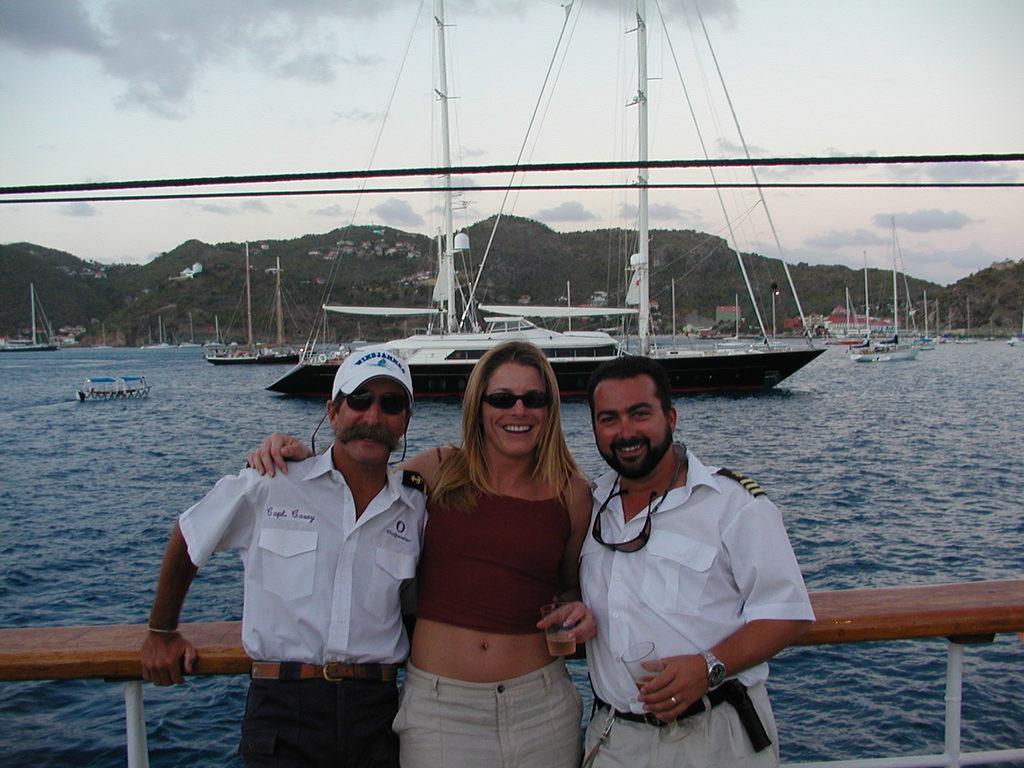Can you describe this image briefly? In this image we can see ships, water, mountains, people and sky. 